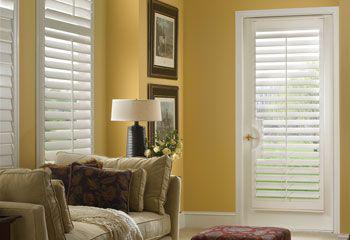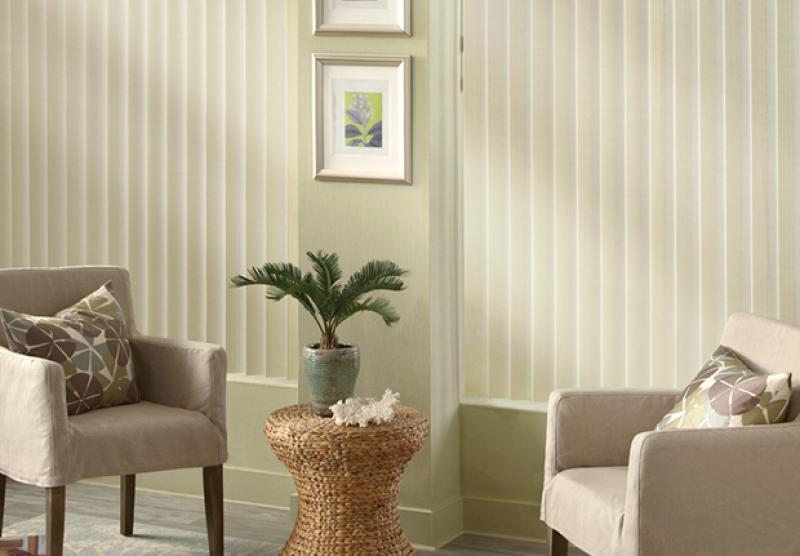The first image is the image on the left, the second image is the image on the right. Examine the images to the left and right. Is the description "The patio doors in one of the images are framed by curtains on either side." accurate? Answer yes or no. No. The first image is the image on the left, the second image is the image on the right. Considering the images on both sides, is "The windows in the left image have drapes." valid? Answer yes or no. No. 